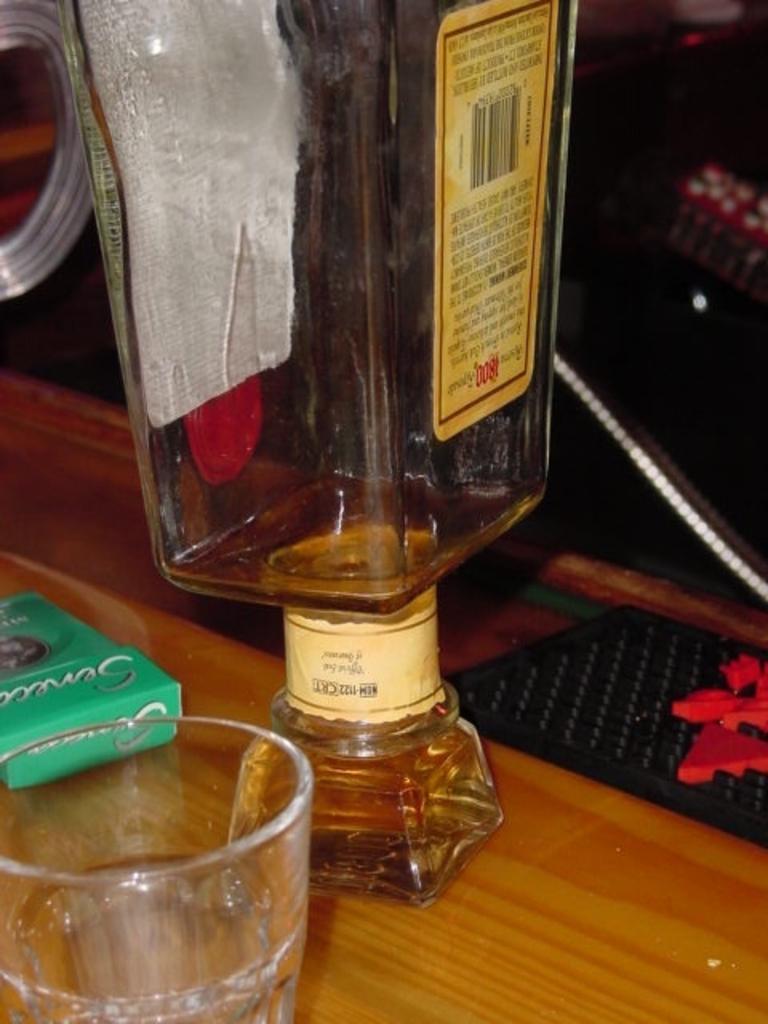Could you give a brief overview of what you see in this image? Here I can see a bottle, glass and some other objects placed on a wooden plank. In the background there are few objects in the dark. 